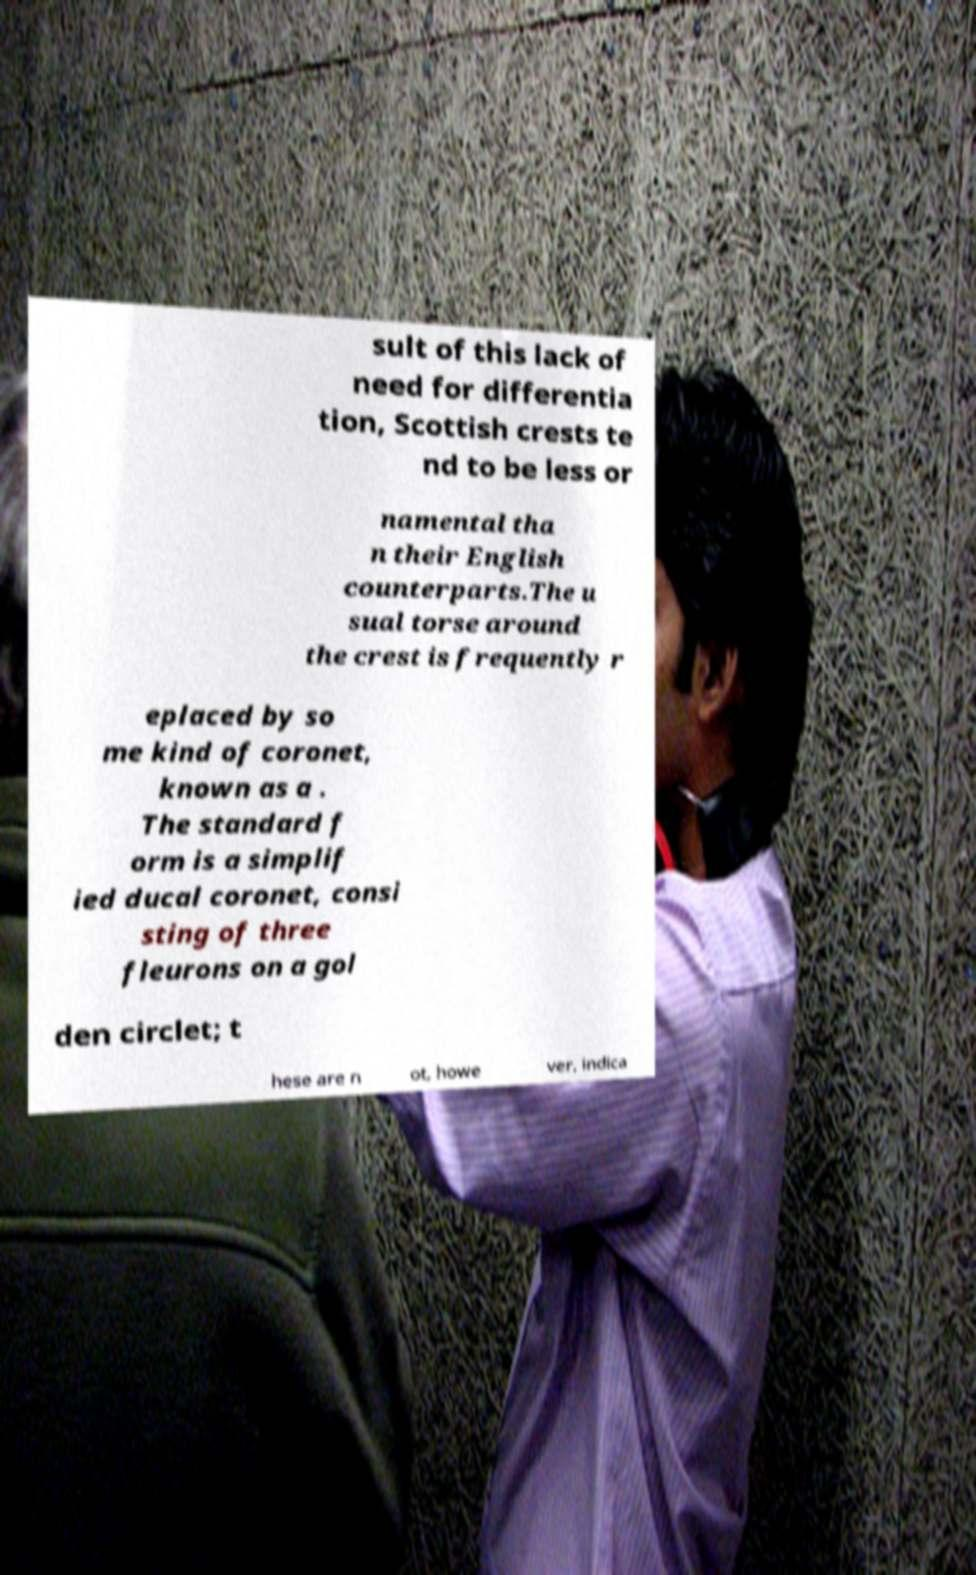Please read and relay the text visible in this image. What does it say? sult of this lack of need for differentia tion, Scottish crests te nd to be less or namental tha n their English counterparts.The u sual torse around the crest is frequently r eplaced by so me kind of coronet, known as a . The standard f orm is a simplif ied ducal coronet, consi sting of three fleurons on a gol den circlet; t hese are n ot, howe ver, indica 